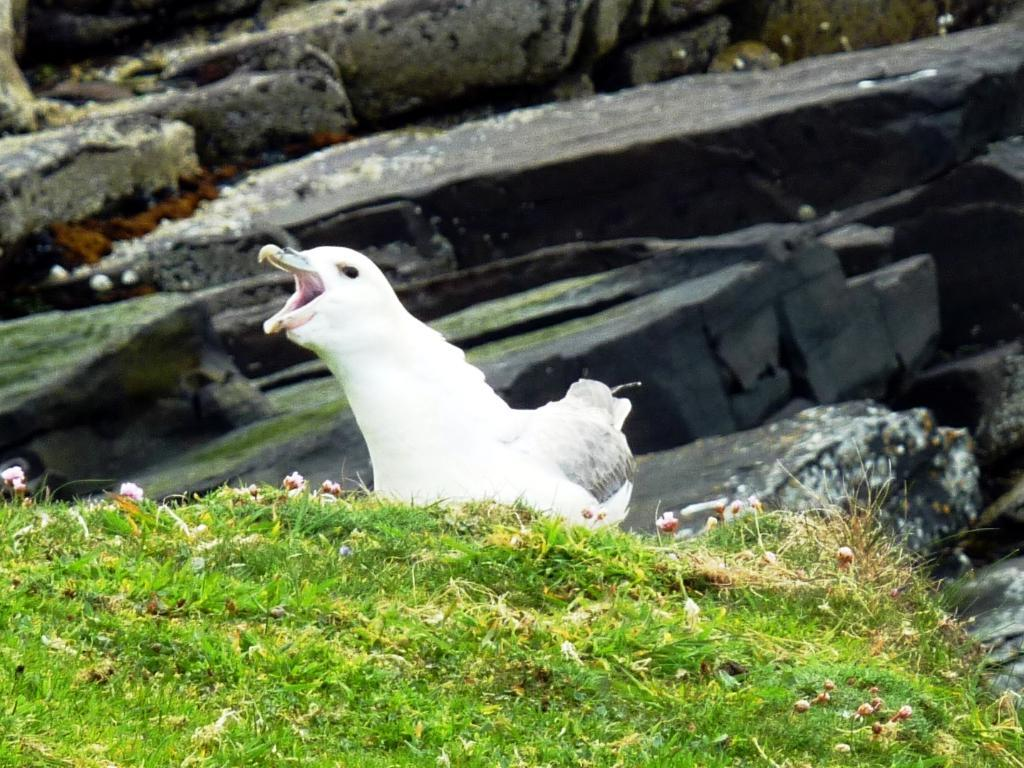What type of animal is present in the image? There is a bird in the picture. What is the color of the bird? The bird is white in color. What type of vegetation can be seen in the image? There is grass in the image. What type of natural feature is visible in the background of the image? There are rocks in the background of the image. What time of day is depicted in the image, based on the position of the sun? The image does not show the position of the sun, so it is not possible to determine the hour from the image. 